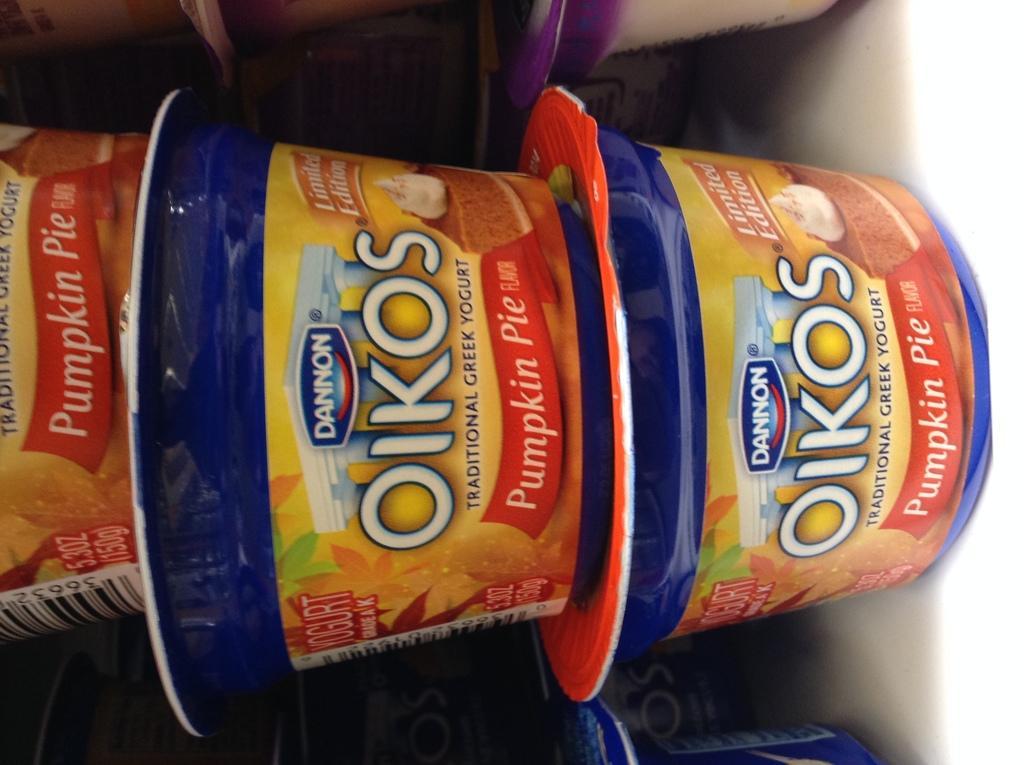Can you describe this image briefly? Here in this picture we can see number of yogurt cups present in the racks over there. 